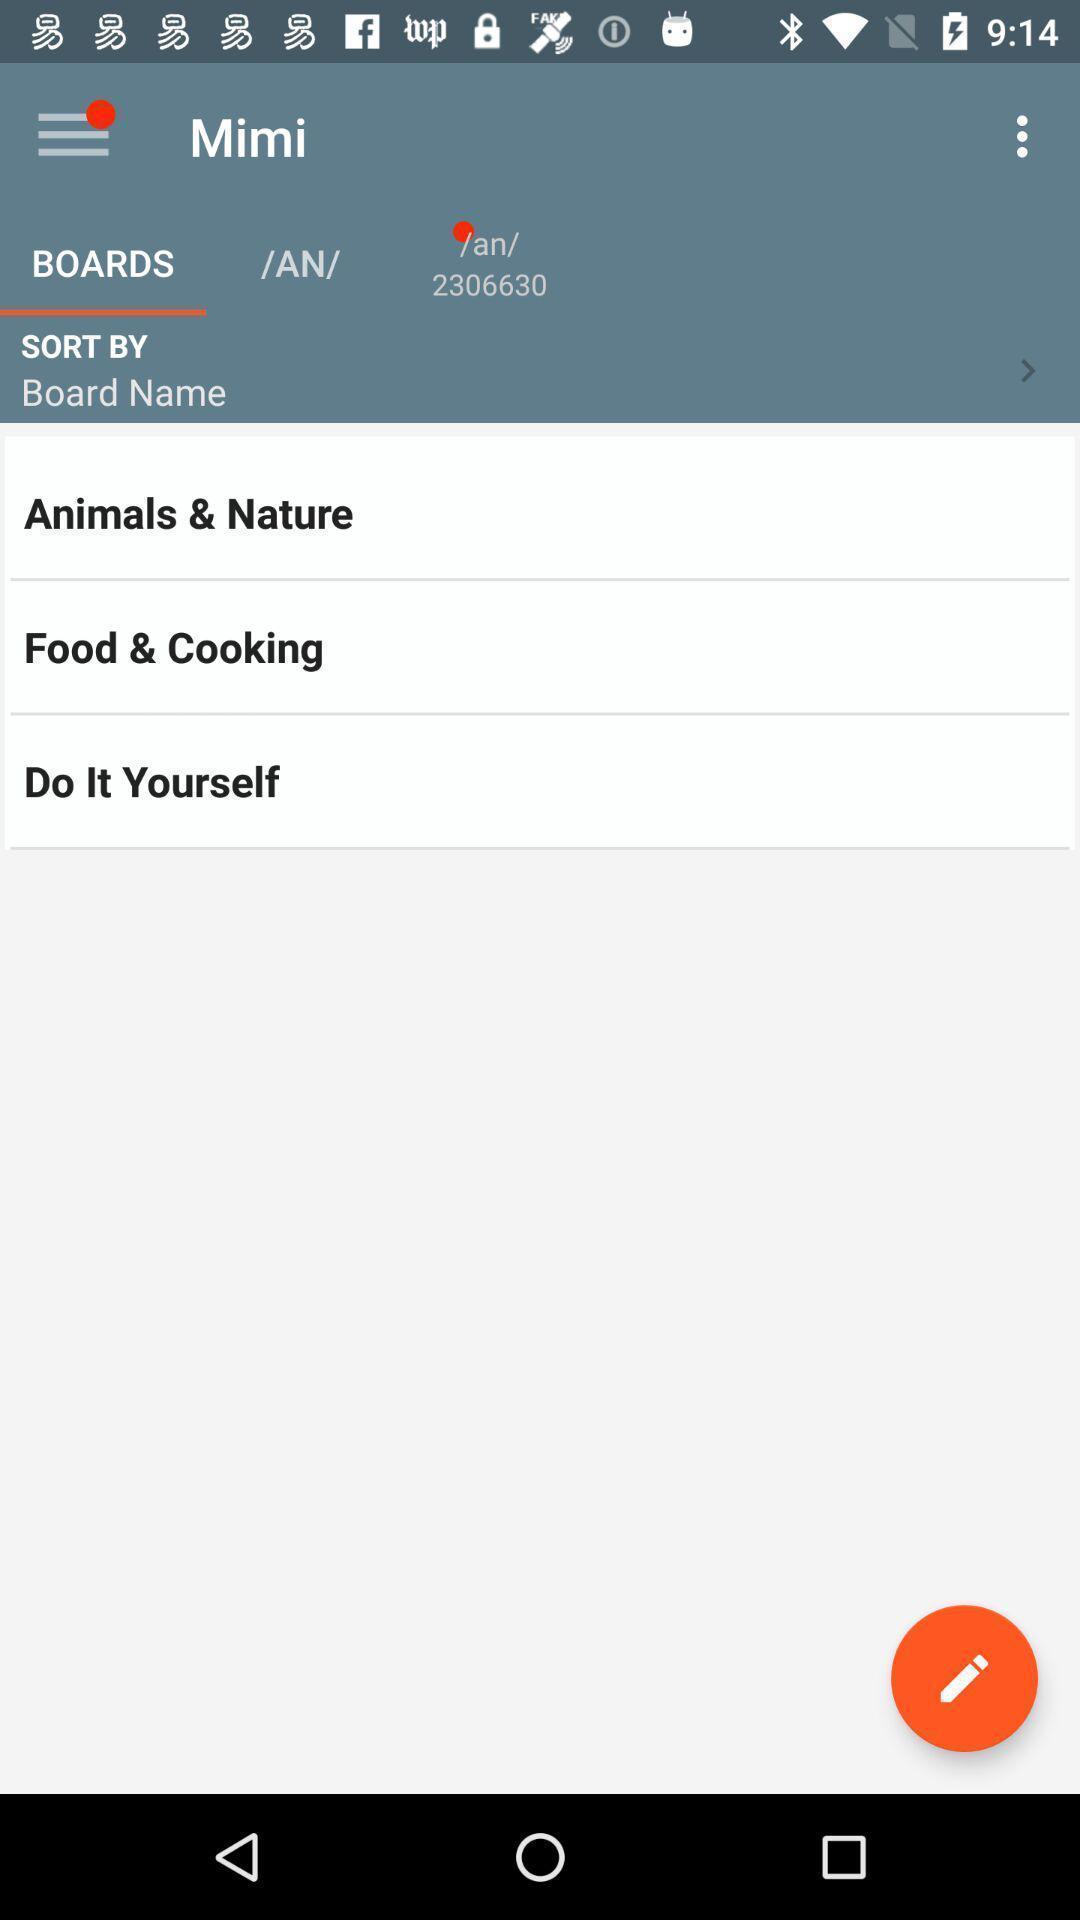Describe the visual elements of this screenshot. Page displaying the board names. 